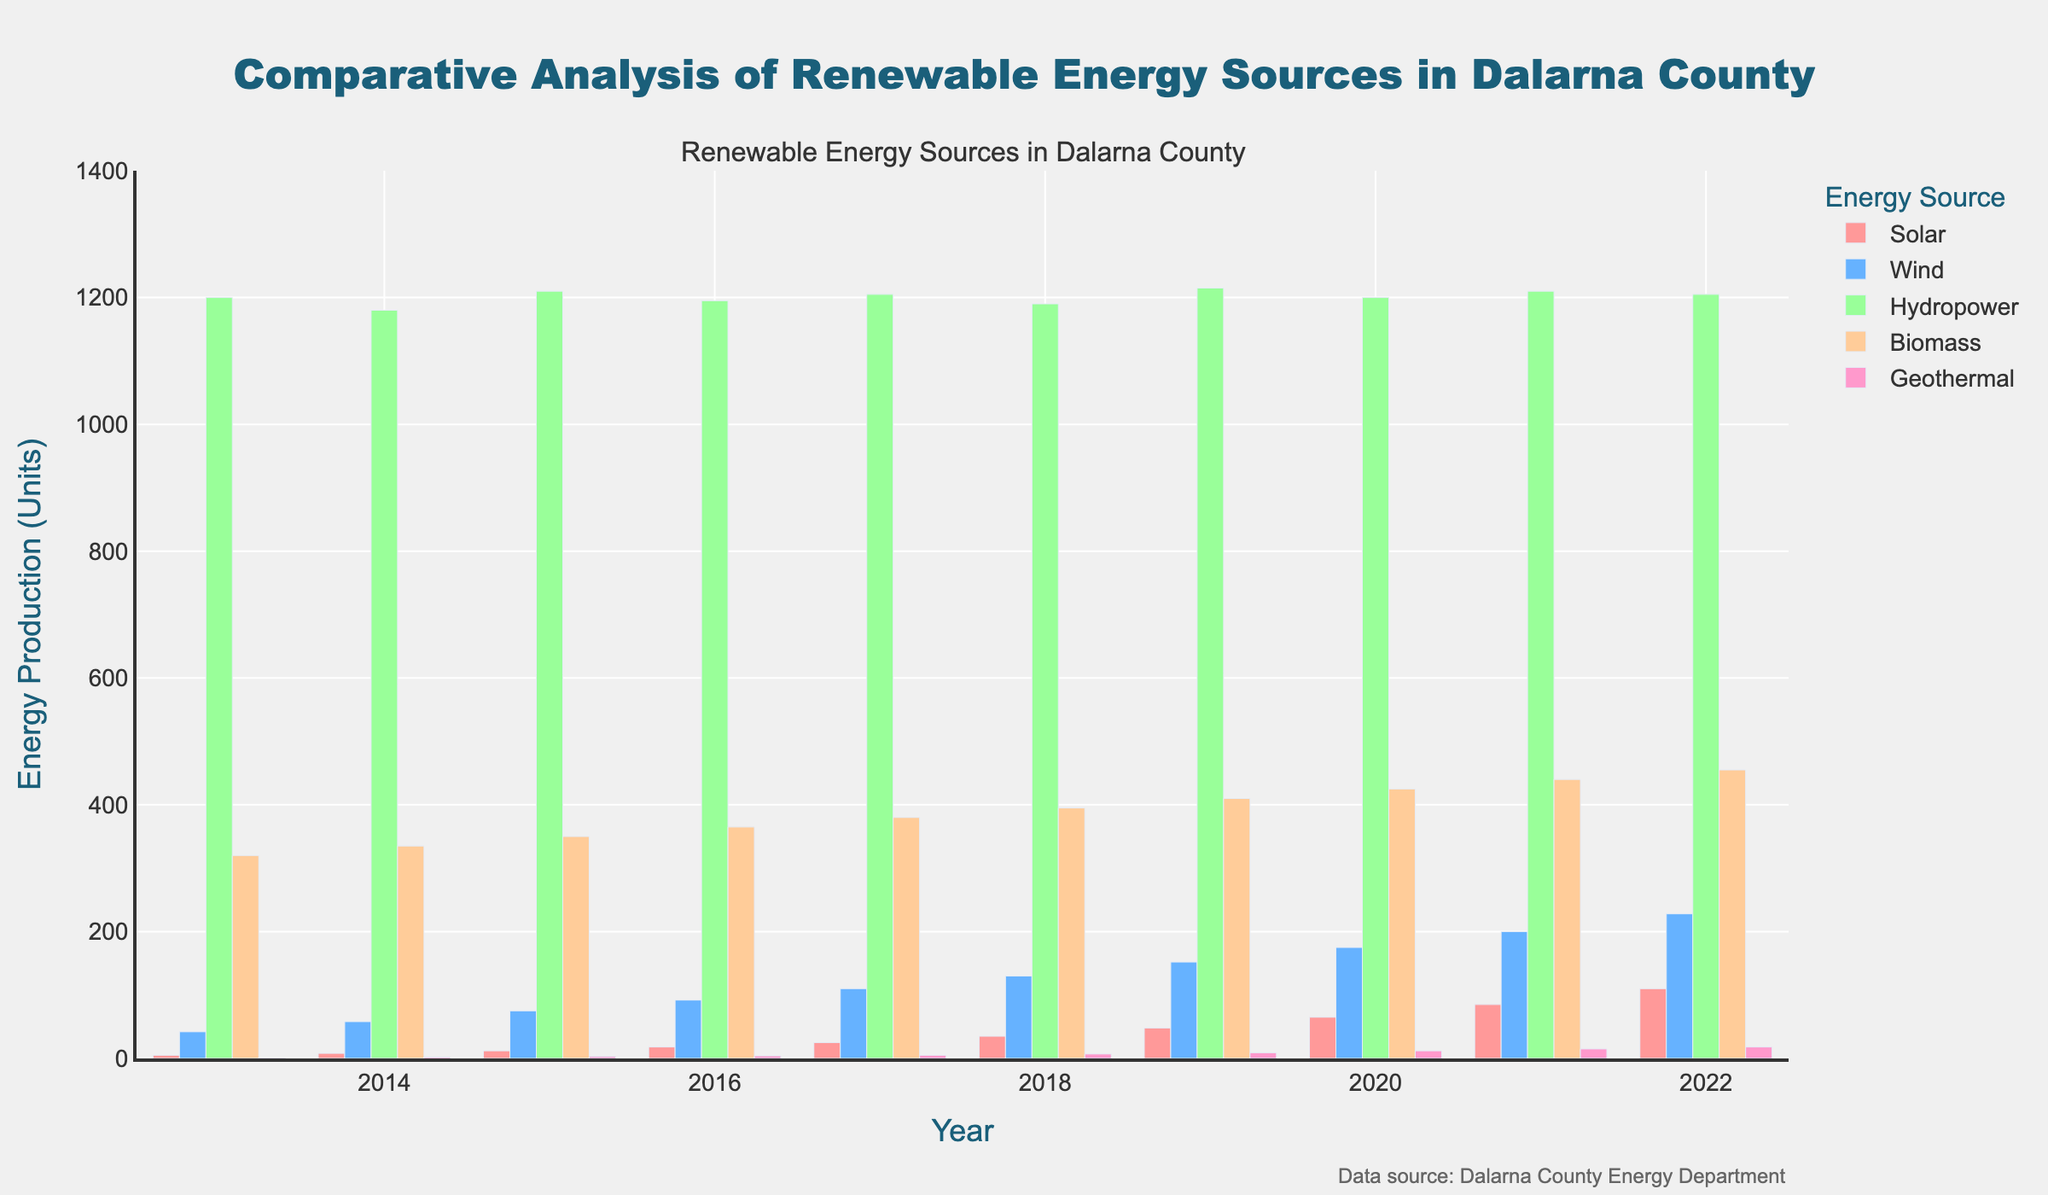What is the trend of solar energy production over the past decade? To answer this, look at the bars representing solar energy for each year from 2013 to 2022. Note how the heights of the bars increase each consecutive year, indicating an upward trend.
Answer: Upward trend In which year did wind energy see the greatest increase compared to the previous year? Compare the height difference between consecutive bars for wind energy across all years. The bars for 2013 to 2022 show the highest increase between 2021 and 2022.
Answer: 2022 Among the five energy sources, which one had the highest production in 2022? Look at the bars for each energy source in the year 2022. Hydropower has the tallest bar, indicating it had the highest production.
Answer: Hydropower What is the sum of energy production from biomass in the first and last year of the decade? Add the value of biomass production in 2013 (320 units) to that in 2022 (455 units).
Answer: 775 units How does the production of geothermal energy in 2022 compare to that in 2013? Compare the heights of the bars for geothermal energy in 2013 and 2022. The bar in 2022 is significantly taller, indicating a higher production.
Answer: Higher in 2022 What is the average production of wind energy over the past decade? Add the wind energy production numbers for each year (42, 58, 75, 92, 110, 130, 152, 175, 200, 228), and divide by the number of years (10). The calculation is (42+58+75+92+110+130+152+175+200+228)/10 = 126.2 units.
Answer: 126.2 units How does biomass energy production in 2018 compare with 2020? Compare the heights of the bars for biomass in 2018 (395 units) and 2020 (425 units). The bar in 2020 is taller, indicating higher production than in 2018.
Answer: Higher in 2020 What is the combined production of wind and solar energy in the year 2019? Add the individual production values for wind (152 units) and solar (48 units) in 2019.
Answer: 200 units Which energy source showed the least variability in production over the past decade? Examine the consistency in bar heights over the decade for all energy sources. Hydropower bars show the least variability, suggesting consistent production.
Answer: Hydropower Can you identify any year where all energy sources except hydropower increased their output compared to the previous year? Look at the annual bar heights for each energy source, comparing them to the previous year. In 2014, except for hydropower (1180 units to 1180 units), all other sources (solar: 5 to 8, wind: 42 to 58, biomass: 320 to 335, geothermal: 1 to 2) increased.
Answer: 2014 